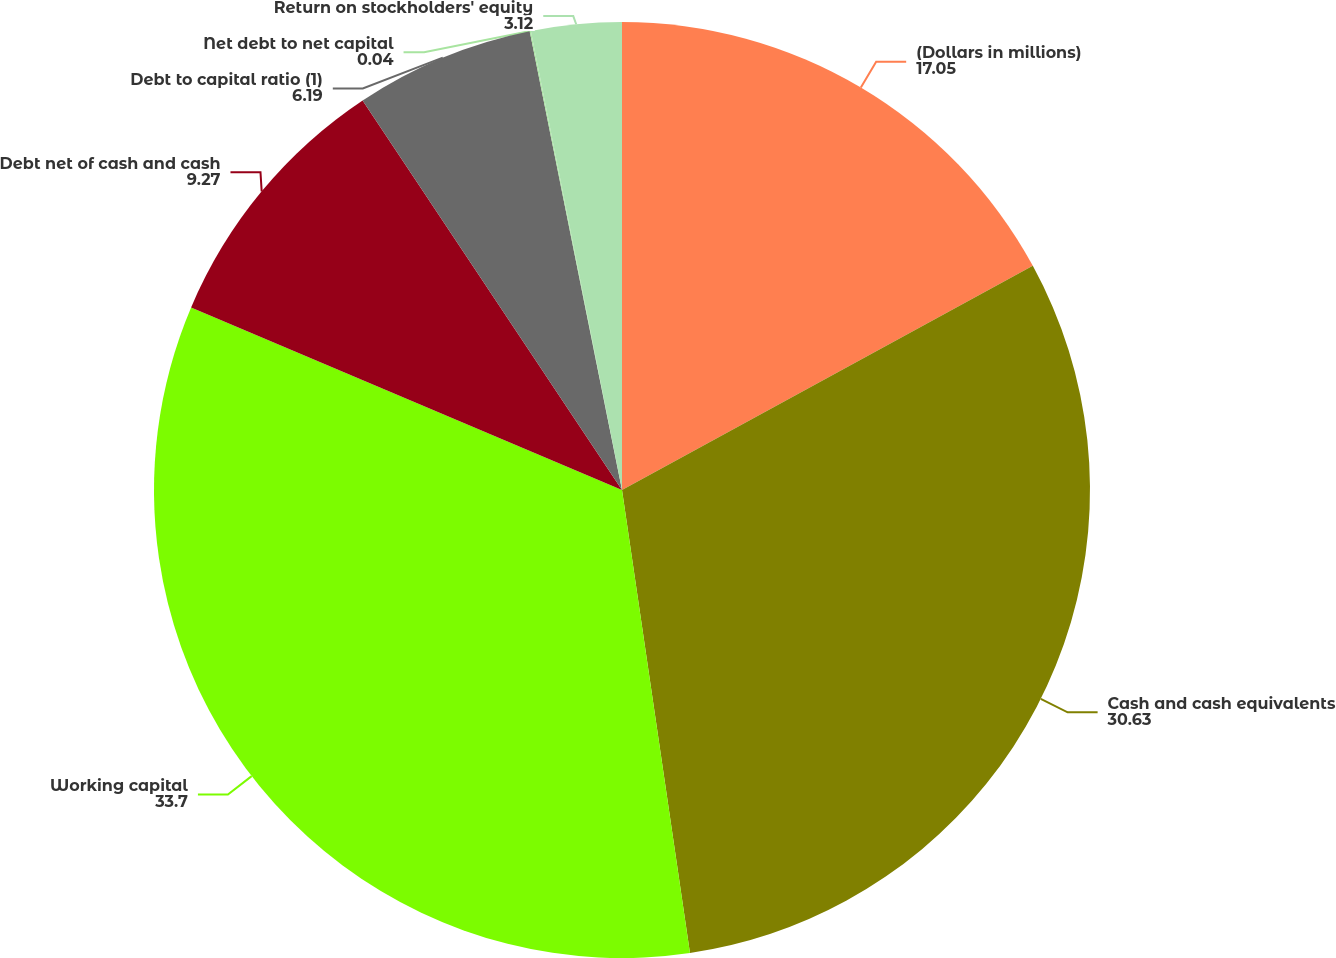Convert chart to OTSL. <chart><loc_0><loc_0><loc_500><loc_500><pie_chart><fcel>(Dollars in millions)<fcel>Cash and cash equivalents<fcel>Working capital<fcel>Debt net of cash and cash<fcel>Debt to capital ratio (1)<fcel>Net debt to net capital<fcel>Return on stockholders' equity<nl><fcel>17.05%<fcel>30.63%<fcel>33.7%<fcel>9.27%<fcel>6.19%<fcel>0.04%<fcel>3.12%<nl></chart> 